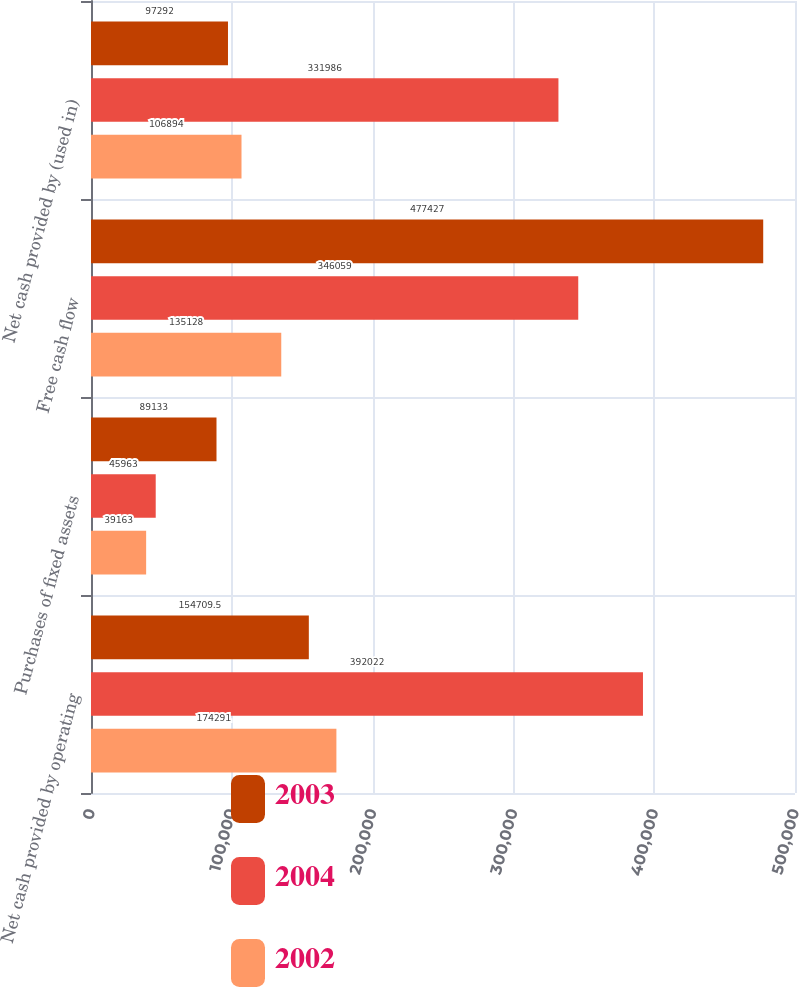Convert chart to OTSL. <chart><loc_0><loc_0><loc_500><loc_500><stacked_bar_chart><ecel><fcel>Net cash provided by operating<fcel>Purchases of fixed assets<fcel>Free cash flow<fcel>Net cash provided by (used in)<nl><fcel>2003<fcel>154710<fcel>89133<fcel>477427<fcel>97292<nl><fcel>2004<fcel>392022<fcel>45963<fcel>346059<fcel>331986<nl><fcel>2002<fcel>174291<fcel>39163<fcel>135128<fcel>106894<nl></chart> 